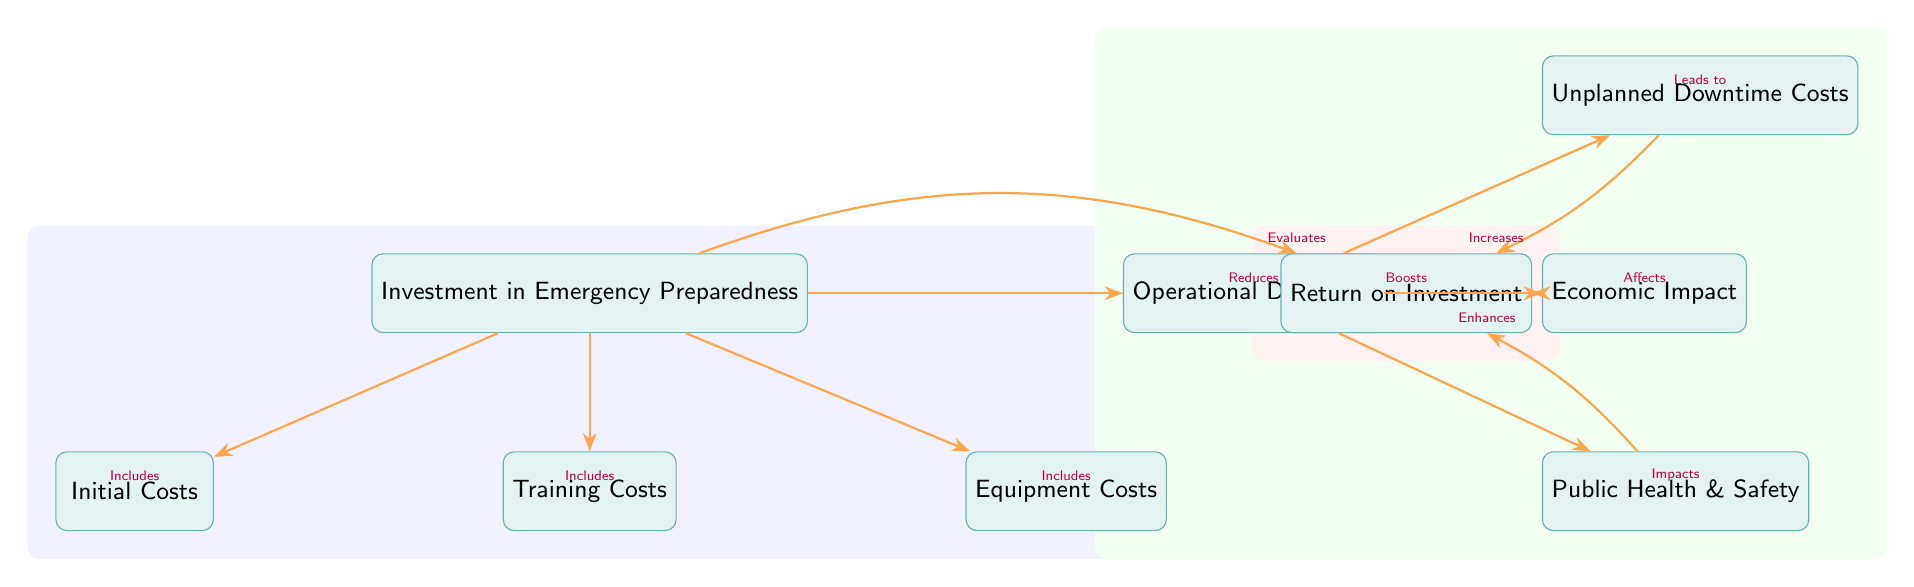What are the initial costs associated with the investment? The diagram includes a direct node labeled "Initial Costs" connected with an arrow from the "Investment in Emergency Preparedness," indicating that these costs are part of the overall investment.
Answer: Initial Costs Which three types of costs are included in the investment? The diagram presents three nodes that branch out from the "Investment in Emergency Preparedness": "Initial Costs," "Training Costs," and "Equipment Costs," which collectively represent the various expenditures involved.
Answer: Initial Costs, Training Costs, Equipment Costs What is the impact of operational downtime? The diagram shows that "Operational Downtime" has arrows leading to three areas: "Unplanned Downtime Costs," "Public Health & Safety," and "Economic Impact," indicating these are all affected by operational downtime.
Answer: Affects unplanned downtime costs, public health & safety, and economic impact How does investment evaluate ROI? The diagram specifies that the "Investment in Emergency Preparedness" evaluates "Return on Investment," showcasing a direct relationship moving from the investment node to the ROI node indicating how the former assesses the effectiveness of the spending.
Answer: Evaluates What effect does public health and safety have on ROI? In the diagram, there is an arrow connecting "Public Health & Safety" to "Return on Investment," indicating that improvements in public health and safety lead to enhancements in ROI, suggesting a positive relationship between the two.
Answer: Enhances What leads to unplanned downtime costs? The diagram demonstrates that "Operational Downtime" leads to "Unplanned Downtime Costs," establishing a cause-and-effect relationship where the former directly impacts the latter.
Answer: Leads to How many direct nodes are there under investment? The diagram illustrates that there are three direct nodes stemming from "Investment in Emergency Preparedness": "Initial Costs," "Training Costs," and "Equipment Costs," indicating a total of three direct nodes under this investment category.
Answer: Three What color represents the background of the investment section? The background for the group of investment-related nodes is illustrated in blue, which visually distinguishes this area in the diagram from others.
Answer: Blue What does the arrow from equipment costs to investment indicate? In the diagram, the arrow from "Investment in Emergency Preparedness" to "Equipment Costs" signifies that equipment costs are part of the overall investment, establishing their inclusion in the total expenses incurred.
Answer: Includes 